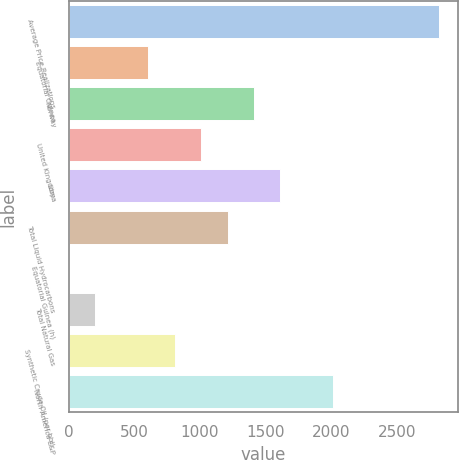Convert chart. <chart><loc_0><loc_0><loc_500><loc_500><bar_chart><fcel>Average Price Realizations<fcel>Equatorial Guinea<fcel>Norway<fcel>United Kingdom<fcel>Libya<fcel>Total Liquid Hydrocarbons<fcel>Equatorial Guinea (h)<fcel>Total Natural Gas<fcel>Synthetic Crude Oil (per bbl)<fcel>North America E&P<nl><fcel>2823.76<fcel>605.28<fcel>1412<fcel>1008.64<fcel>1613.68<fcel>1210.32<fcel>0.24<fcel>201.92<fcel>806.96<fcel>2017.04<nl></chart> 